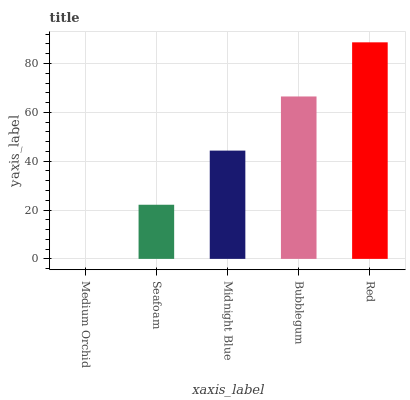Is Medium Orchid the minimum?
Answer yes or no. Yes. Is Red the maximum?
Answer yes or no. Yes. Is Seafoam the minimum?
Answer yes or no. No. Is Seafoam the maximum?
Answer yes or no. No. Is Seafoam greater than Medium Orchid?
Answer yes or no. Yes. Is Medium Orchid less than Seafoam?
Answer yes or no. Yes. Is Medium Orchid greater than Seafoam?
Answer yes or no. No. Is Seafoam less than Medium Orchid?
Answer yes or no. No. Is Midnight Blue the high median?
Answer yes or no. Yes. Is Midnight Blue the low median?
Answer yes or no. Yes. Is Medium Orchid the high median?
Answer yes or no. No. Is Red the low median?
Answer yes or no. No. 